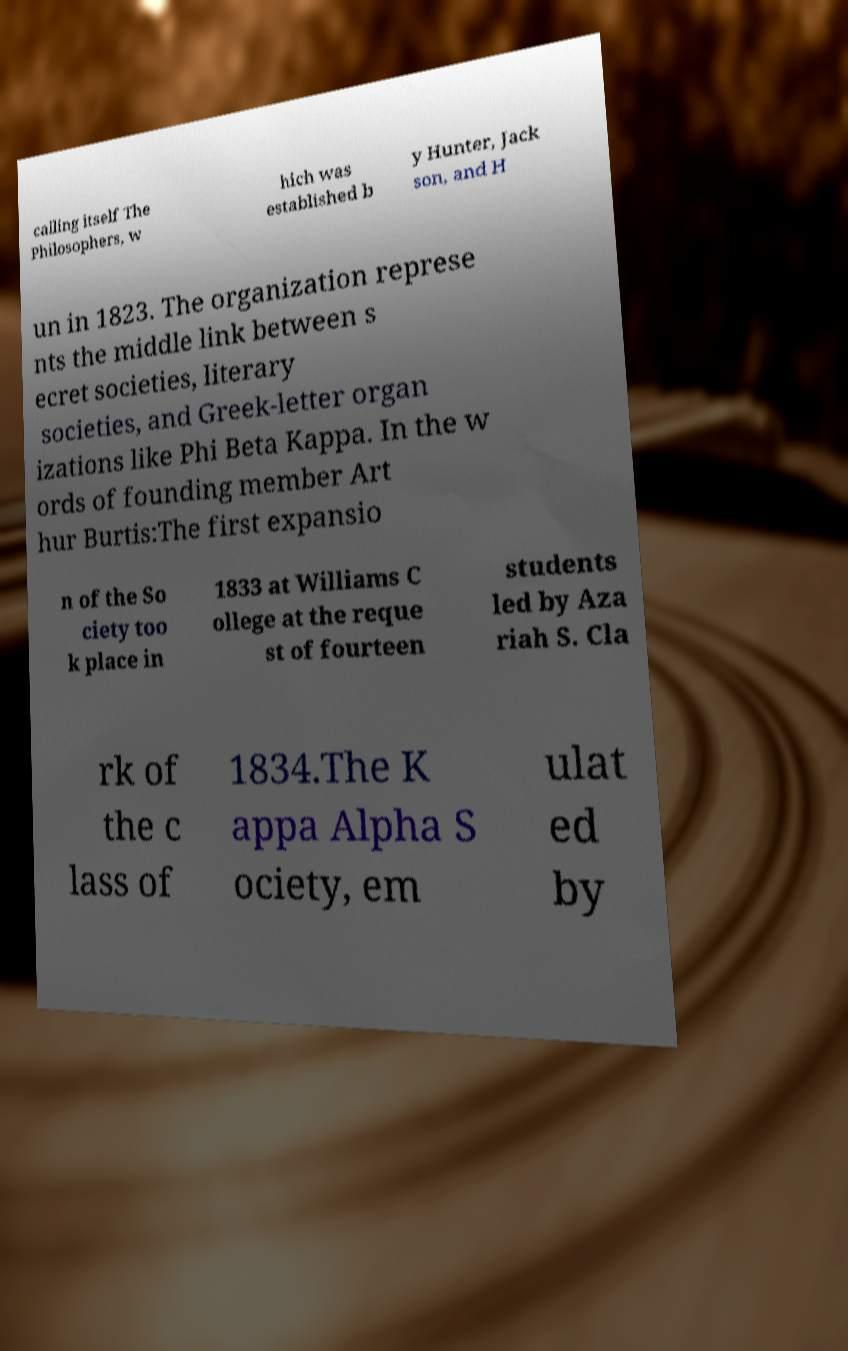What messages or text are displayed in this image? I need them in a readable, typed format. calling itself The Philosophers, w hich was established b y Hunter, Jack son, and H un in 1823. The organization represe nts the middle link between s ecret societies, literary societies, and Greek-letter organ izations like Phi Beta Kappa. In the w ords of founding member Art hur Burtis:The first expansio n of the So ciety too k place in 1833 at Williams C ollege at the reque st of fourteen students led by Aza riah S. Cla rk of the c lass of 1834.The K appa Alpha S ociety, em ulat ed by 